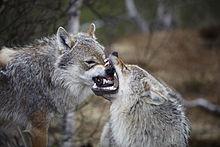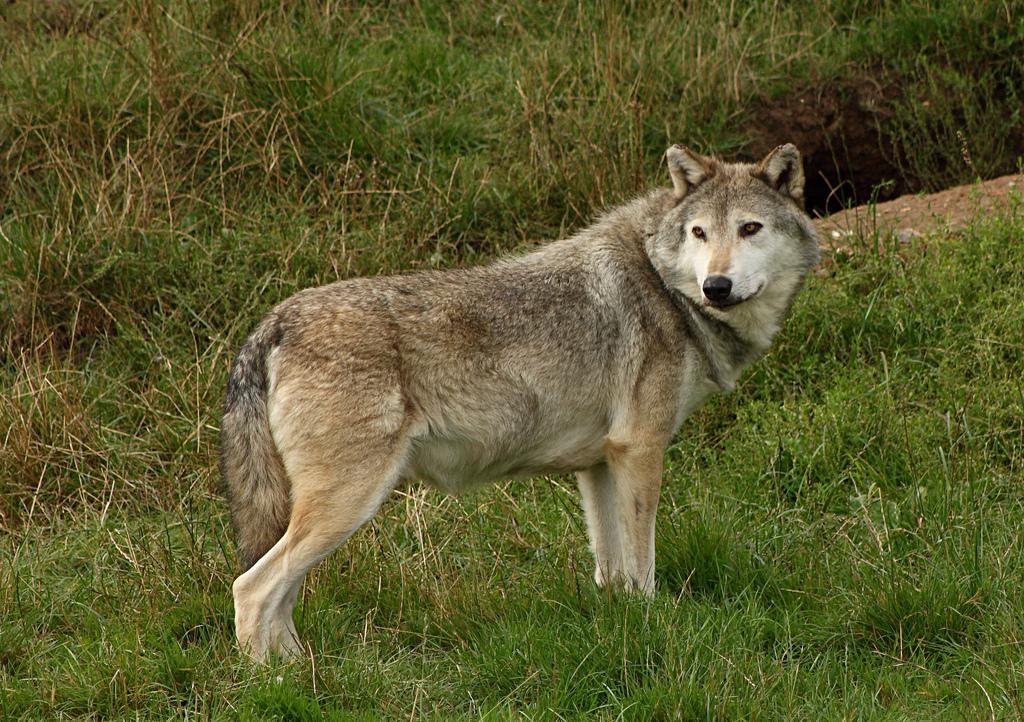The first image is the image on the left, the second image is the image on the right. For the images displayed, is the sentence "At least one wolf is grey and one is tan." factually correct? Answer yes or no. Yes. The first image is the image on the left, the second image is the image on the right. Evaluate the accuracy of this statement regarding the images: "Each image contains exactly one wolf, and one image shows a wolf with an open, non-snarling mouth.". Is it true? Answer yes or no. No. 